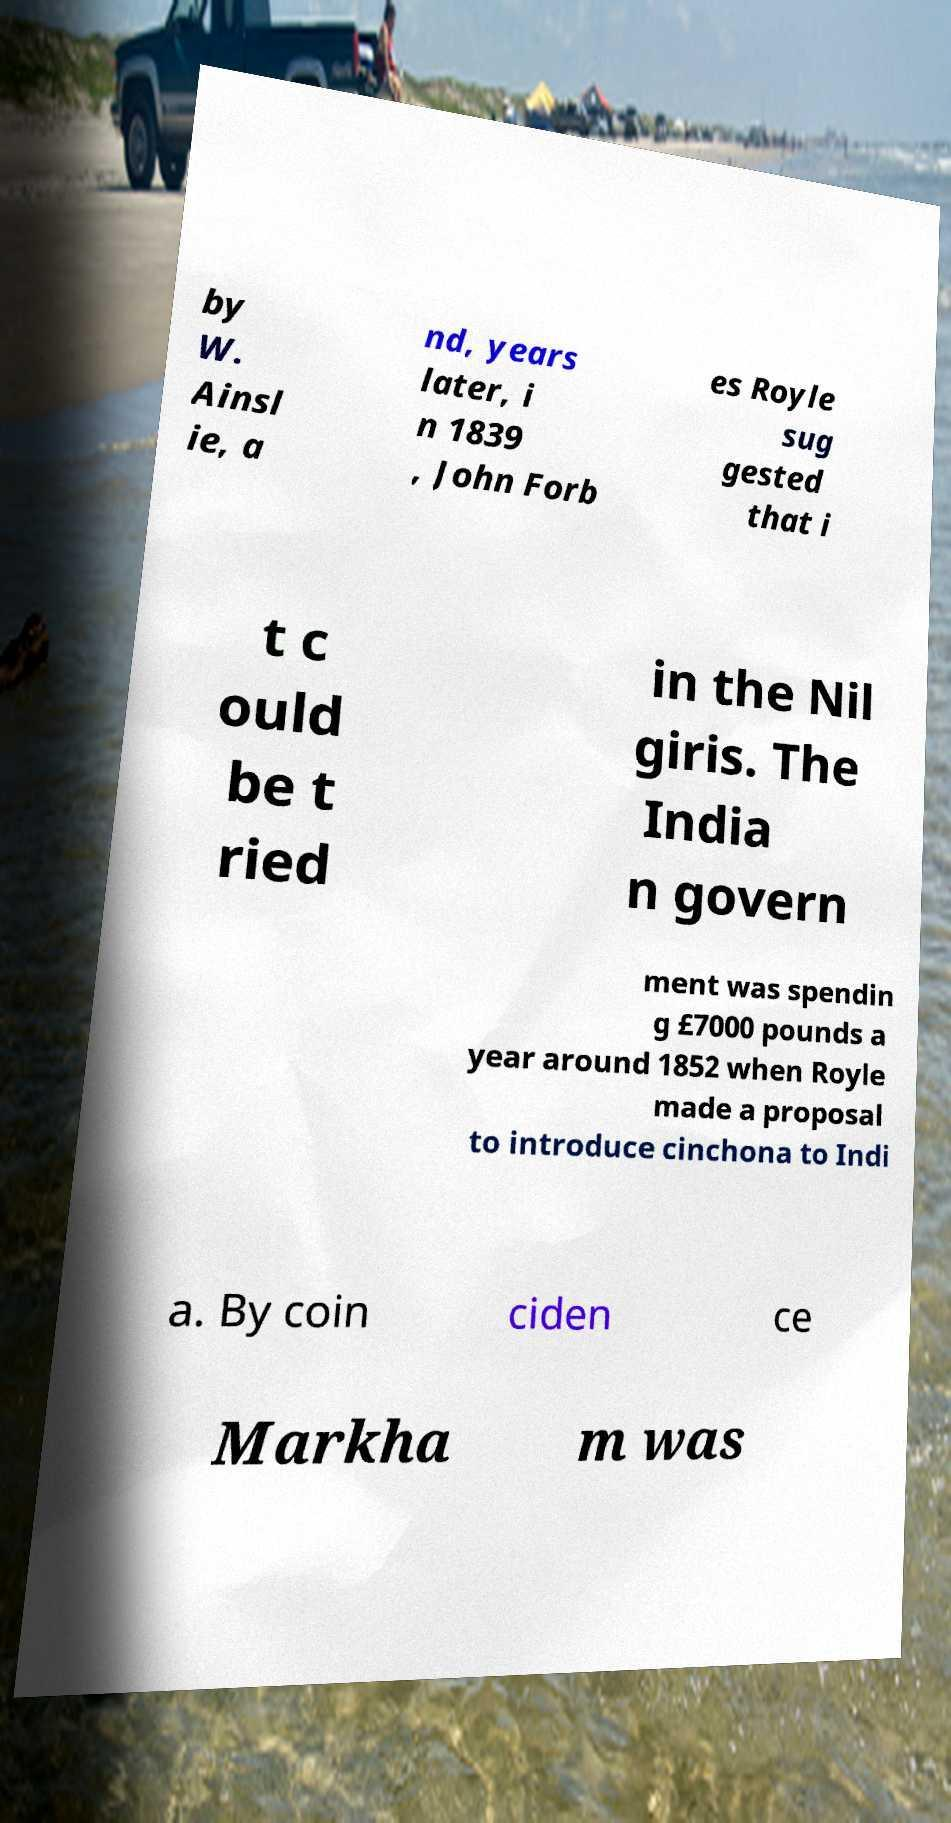Can you accurately transcribe the text from the provided image for me? by W. Ainsl ie, a nd, years later, i n 1839 , John Forb es Royle sug gested that i t c ould be t ried in the Nil giris. The India n govern ment was spendin g £7000 pounds a year around 1852 when Royle made a proposal to introduce cinchona to Indi a. By coin ciden ce Markha m was 